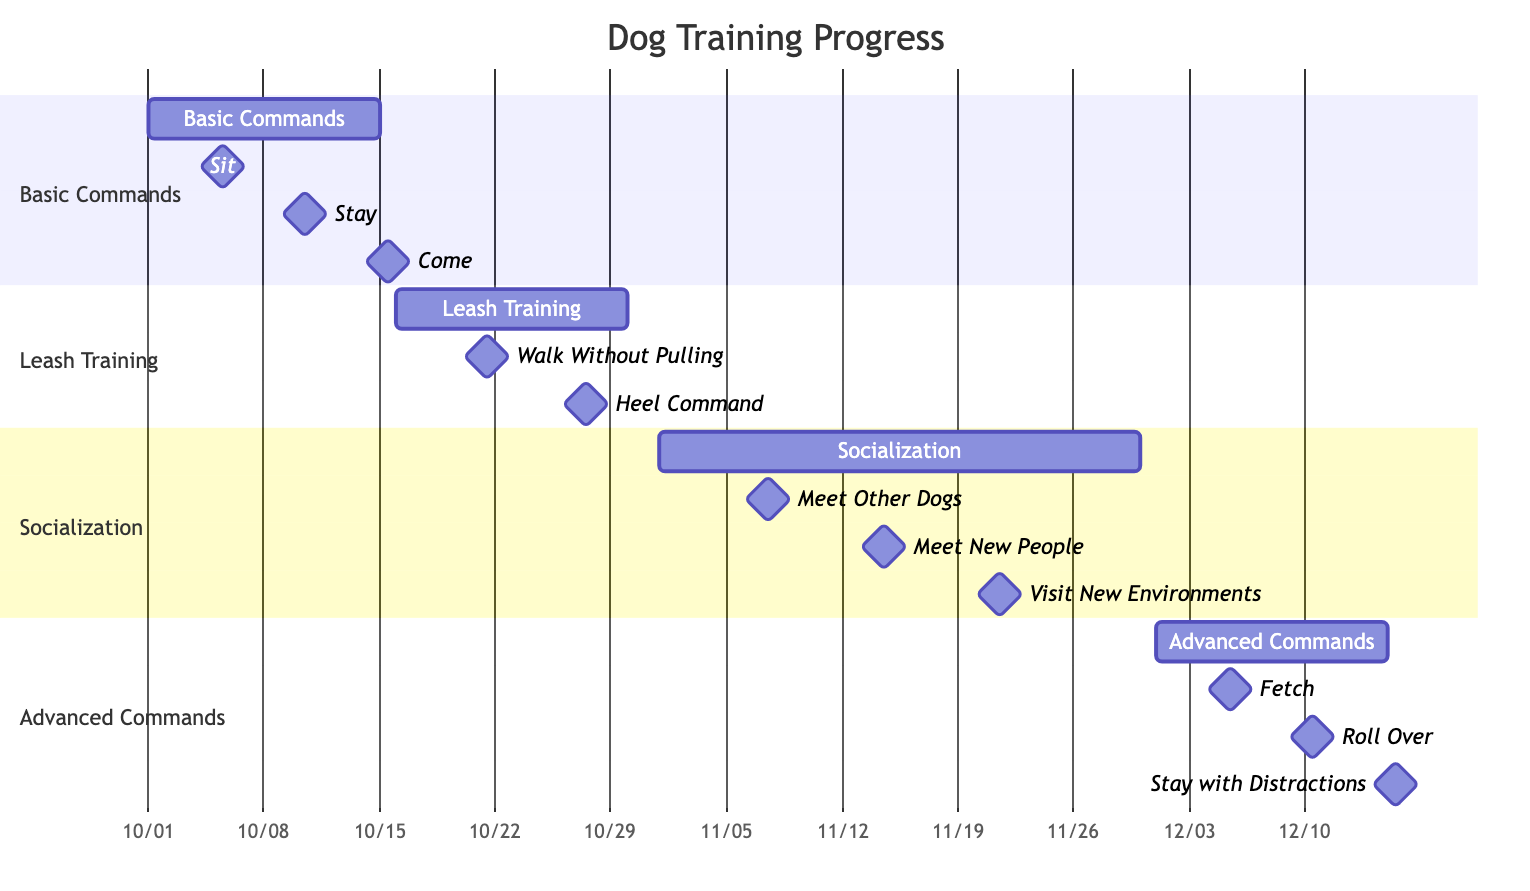What is the start date for the Basic Commands training? The start date for the Basic Commands training is marked at the beginning of the corresponding task bar on the Gantt chart. The given start date is 2023-10-01.
Answer: 2023-10-01 How many milestones are there in the Leash Training section? The Leash Training section has two milestones listed: "Walk Without Pulling" and "Heel Command." By counting these milestones, we find there are 2.
Answer: 2 What is the end date for the Socialization training? The end date for the Socialization training is indicated at the end of the task bar on the Gantt chart. The end date is 2023-11-30.
Answer: 2023-11-30 Which skill is scheduled to be accomplished on 2023-10-10? By looking at the milestones under the Basic Commands section, we see that "Stay" is scheduled for 2023-10-10.
Answer: Stay Which task has the milestone "Fetch"? The milestone "Fetch" is listed under the Advanced Commands section. It is mentioned with a date of 2023-12-05.
Answer: Advanced Commands What is the duration of the Socialization training task? The duration can be calculated by taking the end date (2023-11-30) and subtracting the start date (2023-11-01). This results in 29 days.
Answer: 29 days What is the last milestone for the Advanced Commands section? The last milestone listed in the Advanced Commands section is "Stay with Distractions," scheduled for 2023-12-15.
Answer: Stay with Distractions What is the first milestone in the Basic Commands task? The first milestone under Basic Commands is "Sit," which is set for 2023-10-05.
Answer: Sit What type of diagram is used to represent the dog training progress? The diagram used to represent the dog training progress is a Gantt Chart, which illustrates the schedule and milestones of the tasks involved in dog training.
Answer: Gantt Chart 